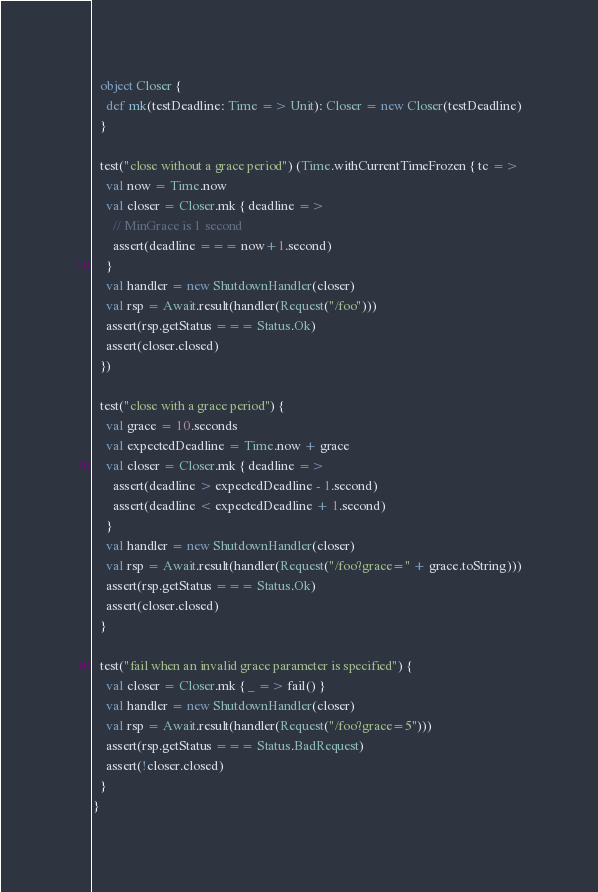Convert code to text. <code><loc_0><loc_0><loc_500><loc_500><_Scala_>
  object Closer {
    def mk(testDeadline: Time => Unit): Closer = new Closer(testDeadline)
  }

  test("close without a grace period") (Time.withCurrentTimeFrozen { tc =>
    val now = Time.now
    val closer = Closer.mk { deadline =>
      // MinGrace is 1 second
      assert(deadline === now+1.second)
    }
    val handler = new ShutdownHandler(closer)
    val rsp = Await.result(handler(Request("/foo")))
    assert(rsp.getStatus === Status.Ok)
    assert(closer.closed)
  })

  test("close with a grace period") {
    val grace = 10.seconds
    val expectedDeadline = Time.now + grace
    val closer = Closer.mk { deadline =>
      assert(deadline > expectedDeadline - 1.second)
      assert(deadline < expectedDeadline + 1.second)
    }
    val handler = new ShutdownHandler(closer)
    val rsp = Await.result(handler(Request("/foo?grace=" + grace.toString)))
    assert(rsp.getStatus === Status.Ok)
    assert(closer.closed)
  }

  test("fail when an invalid grace parameter is specified") {
    val closer = Closer.mk { _ => fail() }
    val handler = new ShutdownHandler(closer)
    val rsp = Await.result(handler(Request("/foo?grace=5")))
    assert(rsp.getStatus === Status.BadRequest)
    assert(!closer.closed)
  }
}
</code> 